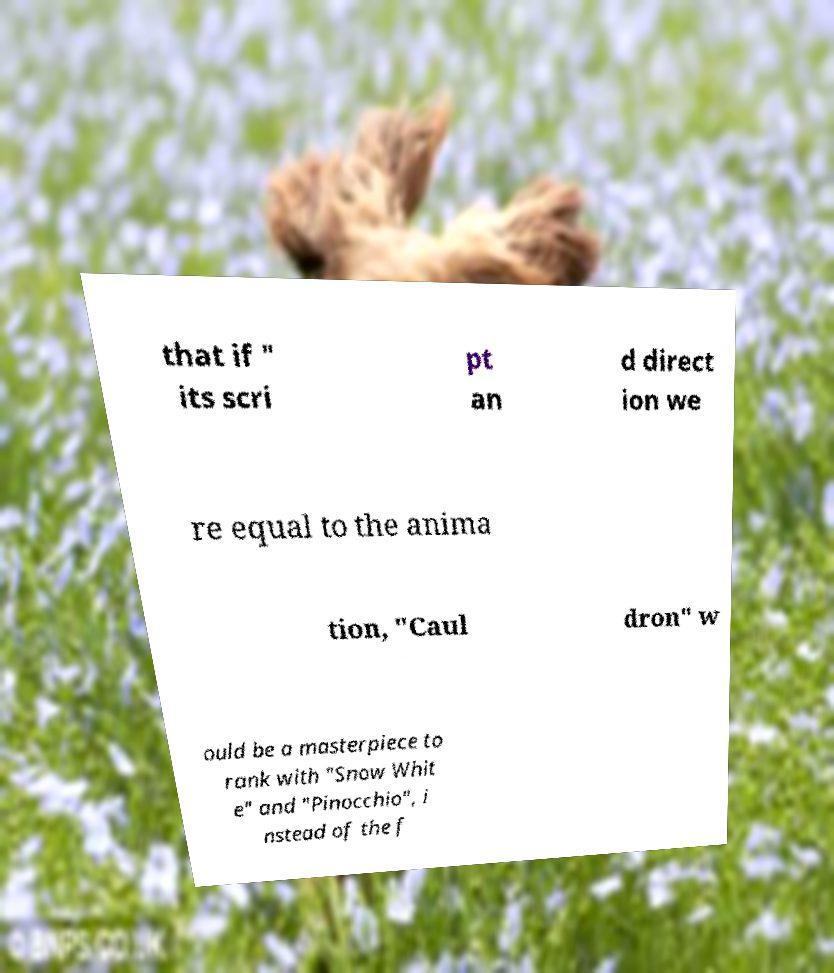Can you read and provide the text displayed in the image?This photo seems to have some interesting text. Can you extract and type it out for me? that if " its scri pt an d direct ion we re equal to the anima tion, "Caul dron" w ould be a masterpiece to rank with "Snow Whit e" and "Pinocchio", i nstead of the f 